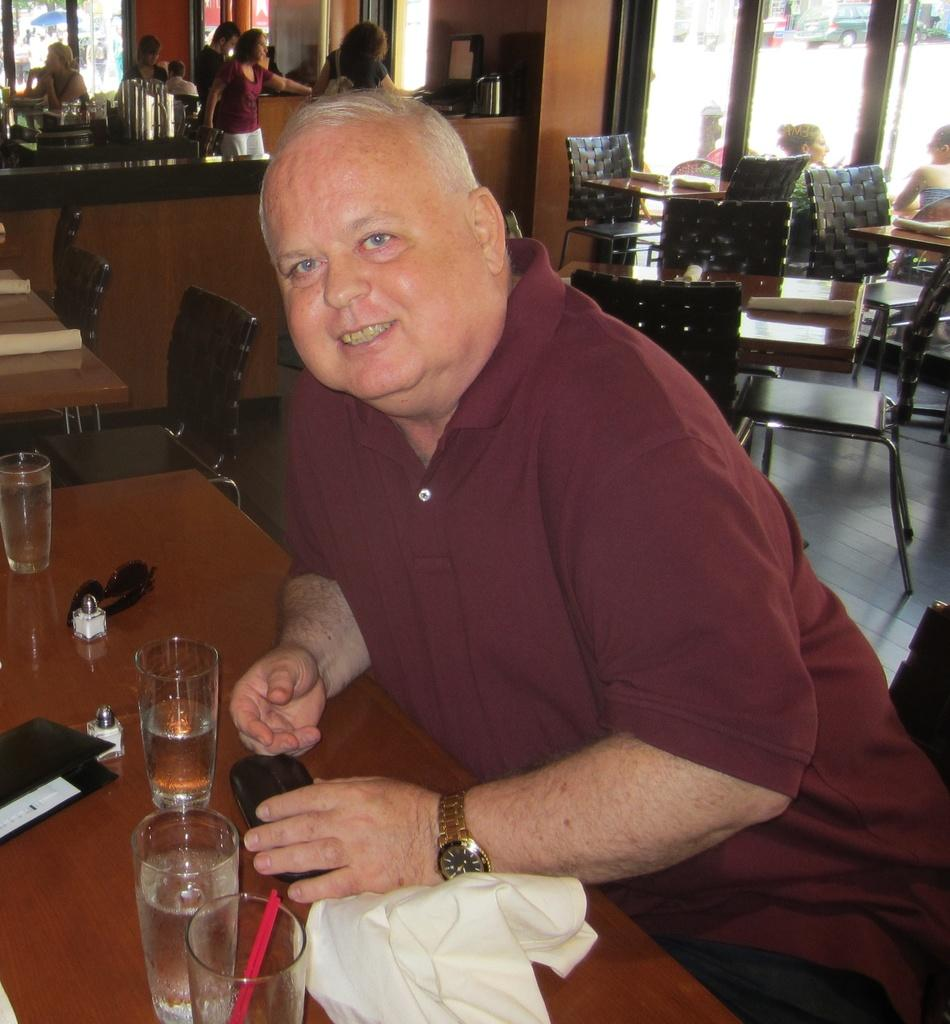What is the man in the image doing? The man is sitting on a chair in the image. What is located in front of the chair? There is a table in front of the chair. What is on the table? There is a glass on the table, and there are objects on the table. Are there any other people in the image? Yes, there are persons standing in the image. What type of door can be seen in the image? There is a glass door in the image. What type of flesh can be seen on the man's arm in the image? There is no flesh visible on the man's arm in the image; it is not possible to determine the texture or appearance of his skin. What is the plot of the story unfolding in the image? There is no story or plot depicted in the image; it is a static scene with people and objects. 